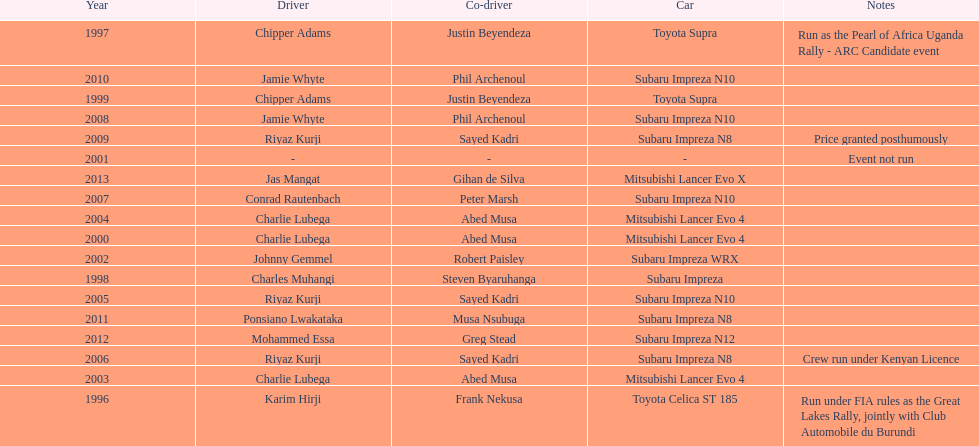Chipper adams and justin beyendeza have how mnay wins? 2. 